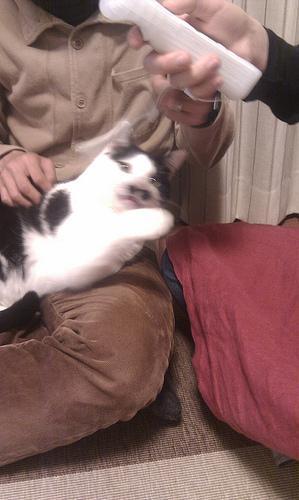How many cats are there?
Give a very brief answer. 1. 